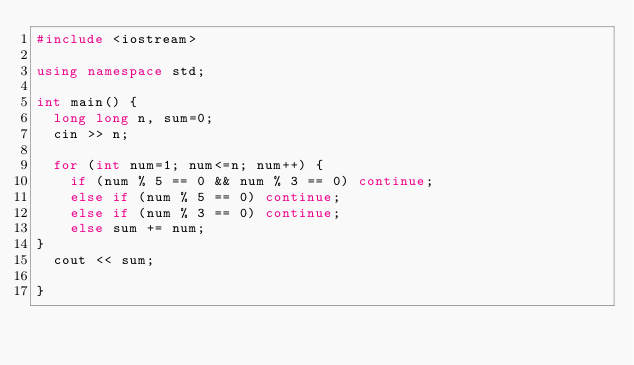Convert code to text. <code><loc_0><loc_0><loc_500><loc_500><_C++_>#include <iostream>

using namespace std;

int main() {
  long long n, sum=0;
  cin >> n;
  
  for (int num=1; num<=n; num++) {
  	if (num % 5 == 0 && num % 3 == 0) continue;
    else if (num % 5 == 0) continue;
    else if (num % 3 == 0) continue;
    else sum += num;
}
  cout << sum;
  
}</code> 